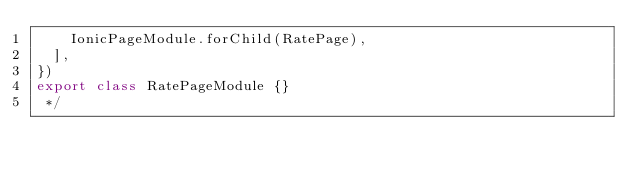Convert code to text. <code><loc_0><loc_0><loc_500><loc_500><_TypeScript_>    IonicPageModule.forChild(RatePage),
  ],
})
export class RatePageModule {}
 */
</code> 